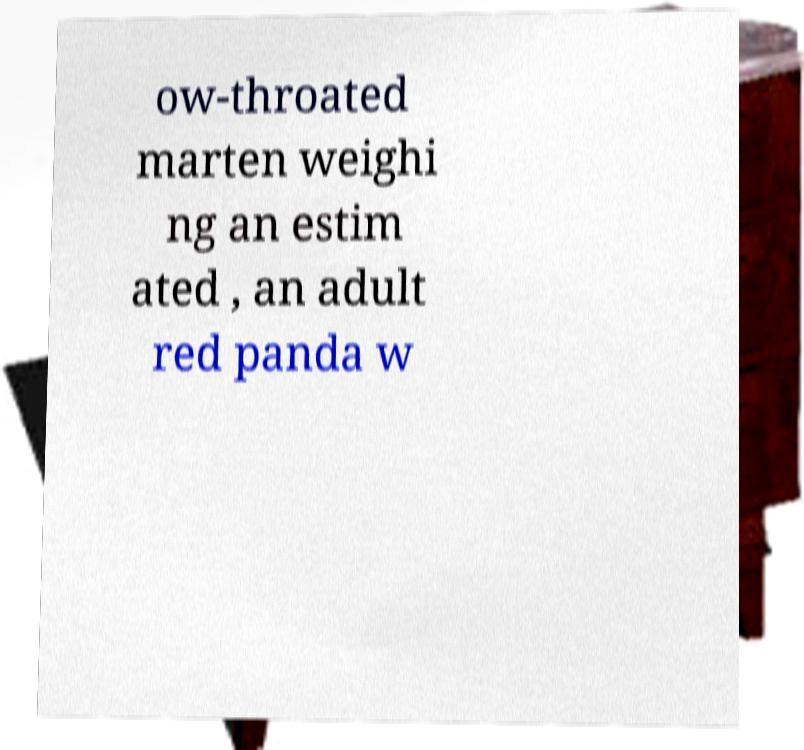Please read and relay the text visible in this image. What does it say? ow-throated marten weighi ng an estim ated , an adult red panda w 